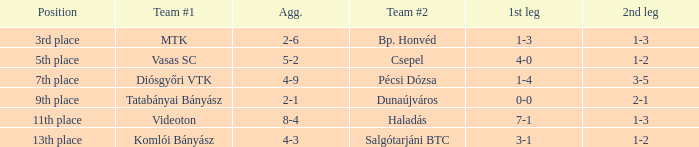I'm looking to parse the entire table for insights. Could you assist me with that? {'header': ['Position', 'Team #1', 'Agg.', 'Team #2', '1st leg', '2nd leg'], 'rows': [['3rd place', 'MTK', '2-6', 'Bp. Honvéd', '1-3', '1-3'], ['5th place', 'Vasas SC', '5-2', 'Csepel', '4-0', '1-2'], ['7th place', 'Diósgyőri VTK', '4-9', 'Pécsi Dózsa', '1-4', '3-5'], ['9th place', 'Tatabányai Bányász', '2-1', 'Dunaújváros', '0-0', '2-1'], ['11th place', 'Videoton', '8-4', 'Haladás', '7-1', '1-3'], ['13th place', 'Komlói Bányász', '4-3', 'Salgótarjáni BTC', '3-1', '1-2']]} How many positions correspond to a 1-3 1st leg? 1.0. 